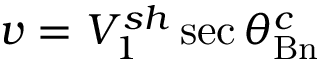Convert formula to latex. <formula><loc_0><loc_0><loc_500><loc_500>v = V _ { 1 } ^ { s h } \sec { \theta _ { B n } ^ { c } }</formula> 